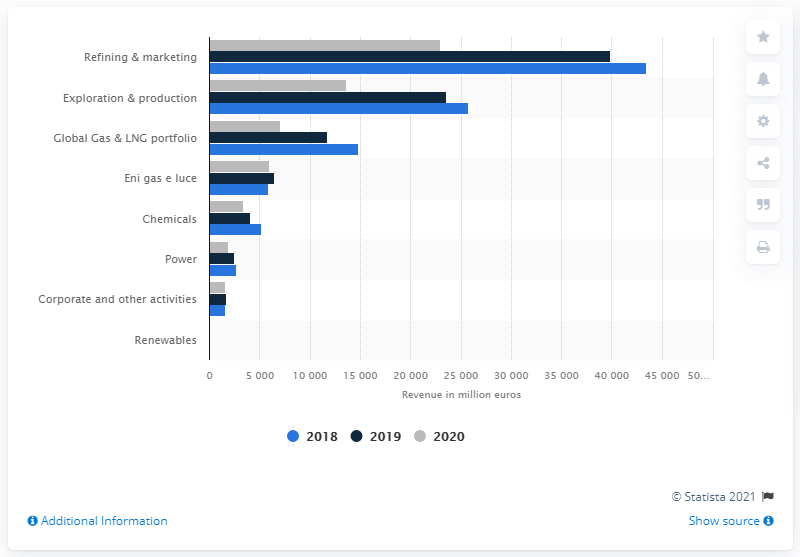Give some essential details in this illustration. Refining and marketing is the most profitable business segment for Eni S.p.A. Eni's operating revenue in 2020 was 22,965. 